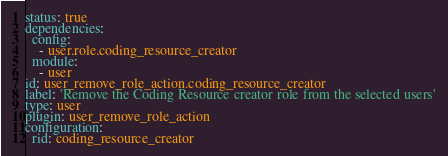<code> <loc_0><loc_0><loc_500><loc_500><_YAML_>status: true
dependencies:
  config:
    - user.role.coding_resource_creator
  module:
    - user
id: user_remove_role_action.coding_resource_creator
label: 'Remove the Coding Resource creator role from the selected users'
type: user
plugin: user_remove_role_action
configuration:
  rid: coding_resource_creator
</code> 